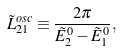<formula> <loc_0><loc_0><loc_500><loc_500>\tilde { L } _ { 2 1 } ^ { o s c } \equiv \frac { 2 \pi } { \tilde { E } _ { 2 } ^ { 0 } - \tilde { E } _ { 1 } ^ { 0 } } ,</formula> 